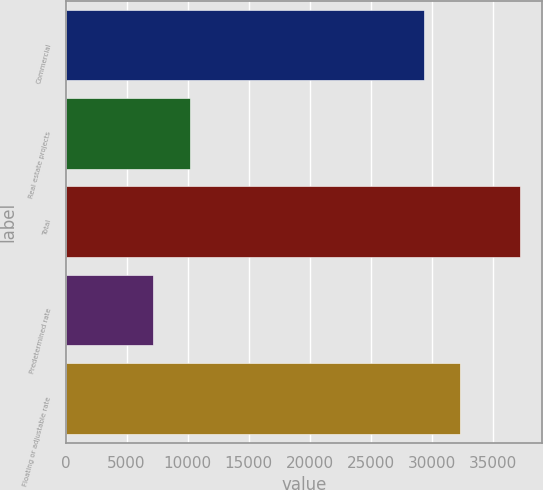Convert chart to OTSL. <chart><loc_0><loc_0><loc_500><loc_500><bar_chart><fcel>Commercial<fcel>Real estate projects<fcel>Total<fcel>Predetermined rate<fcel>Floating or adjustable rate<nl><fcel>29313<fcel>10194<fcel>37158<fcel>7198<fcel>32309<nl></chart> 